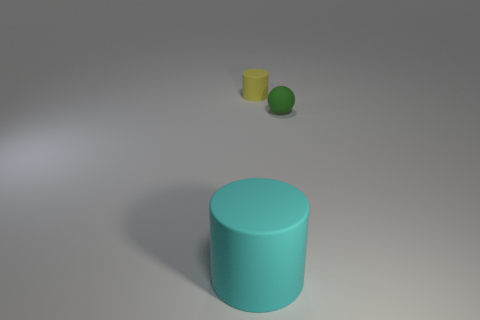What time of day does the lighting in the image suggest? The soft shadows and neutral lighting in the image imply an overcast daylight scenario or diffused artificial lighting, typically indicating either an outdoor scene on a cloudy day or an indoor setting with ample ambient light. Is there any indication of movement or stillness in this scene? The scene is captured in a still image with no blurring or visual cues of movement. The sharp outlines and clear shadows of the objects suggest a moment of stillness, with no action or dynamic interaction taking place. 